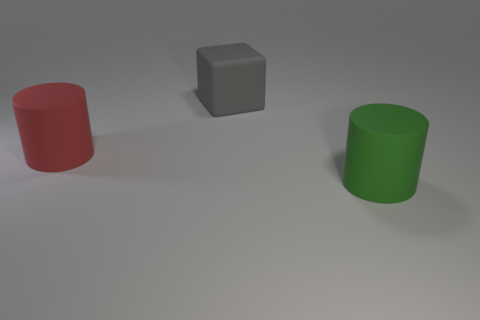What is the color of the other cylinder that is made of the same material as the big green cylinder?
Your response must be concise. Red. Do the green thing and the cylinder behind the green cylinder have the same material?
Offer a terse response. Yes. The block is what color?
Your answer should be compact. Gray. There is a object that is to the right of the gray matte thing that is left of the green cylinder; what number of gray things are behind it?
Your answer should be very brief. 1. There is a big cylinder on the left side of the big cylinder that is on the right side of the big cylinder that is to the left of the green matte thing; what is it made of?
Your answer should be compact. Rubber. Is the shape of the big object to the left of the big gray block the same as  the green object?
Your response must be concise. Yes. What number of metal objects are either big blue cylinders or large things?
Keep it short and to the point. 0. Is there another block that has the same size as the cube?
Offer a terse response. No. Are there more gray cubes right of the red rubber cylinder than big cyan balls?
Your response must be concise. Yes. What number of small things are either rubber blocks or yellow matte blocks?
Your response must be concise. 0. 